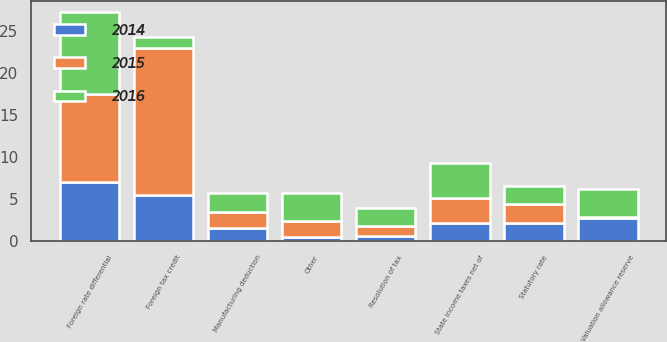Convert chart to OTSL. <chart><loc_0><loc_0><loc_500><loc_500><stacked_bar_chart><ecel><fcel>Statutory rate<fcel>State income taxes net of<fcel>Foreign tax credit<fcel>Foreign rate differential<fcel>Resolution of tax<fcel>Valuation allowance reserve<fcel>Manufacturing deduction<fcel>Other<nl><fcel>2016<fcel>2.2<fcel>4.2<fcel>1.3<fcel>9.8<fcel>2.1<fcel>3.3<fcel>2.2<fcel>3.3<nl><fcel>2015<fcel>2.2<fcel>3<fcel>17.5<fcel>10.5<fcel>1.2<fcel>0.2<fcel>2<fcel>1.9<nl><fcel>2014<fcel>2.2<fcel>2.1<fcel>5.5<fcel>7<fcel>0.6<fcel>2.7<fcel>1.5<fcel>0.5<nl></chart> 